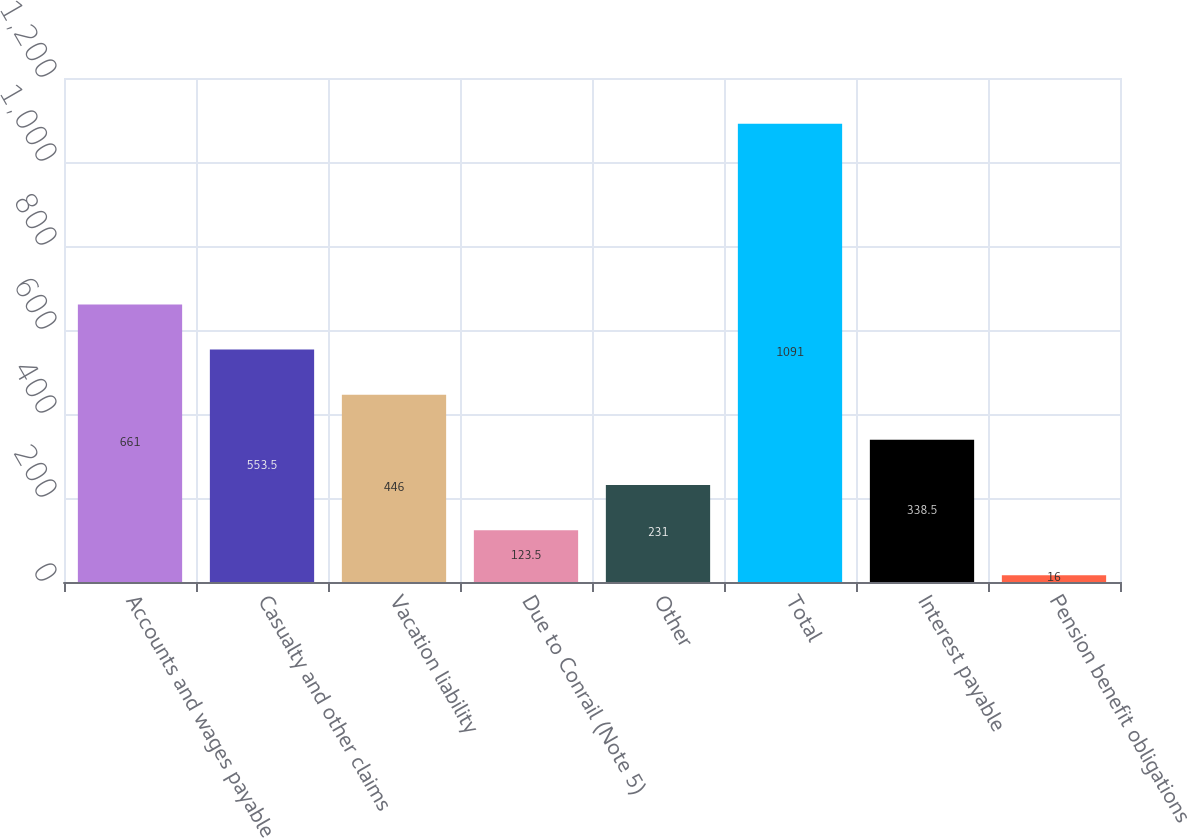Convert chart. <chart><loc_0><loc_0><loc_500><loc_500><bar_chart><fcel>Accounts and wages payable<fcel>Casualty and other claims<fcel>Vacation liability<fcel>Due to Conrail (Note 5)<fcel>Other<fcel>Total<fcel>Interest payable<fcel>Pension benefit obligations<nl><fcel>661<fcel>553.5<fcel>446<fcel>123.5<fcel>231<fcel>1091<fcel>338.5<fcel>16<nl></chart> 